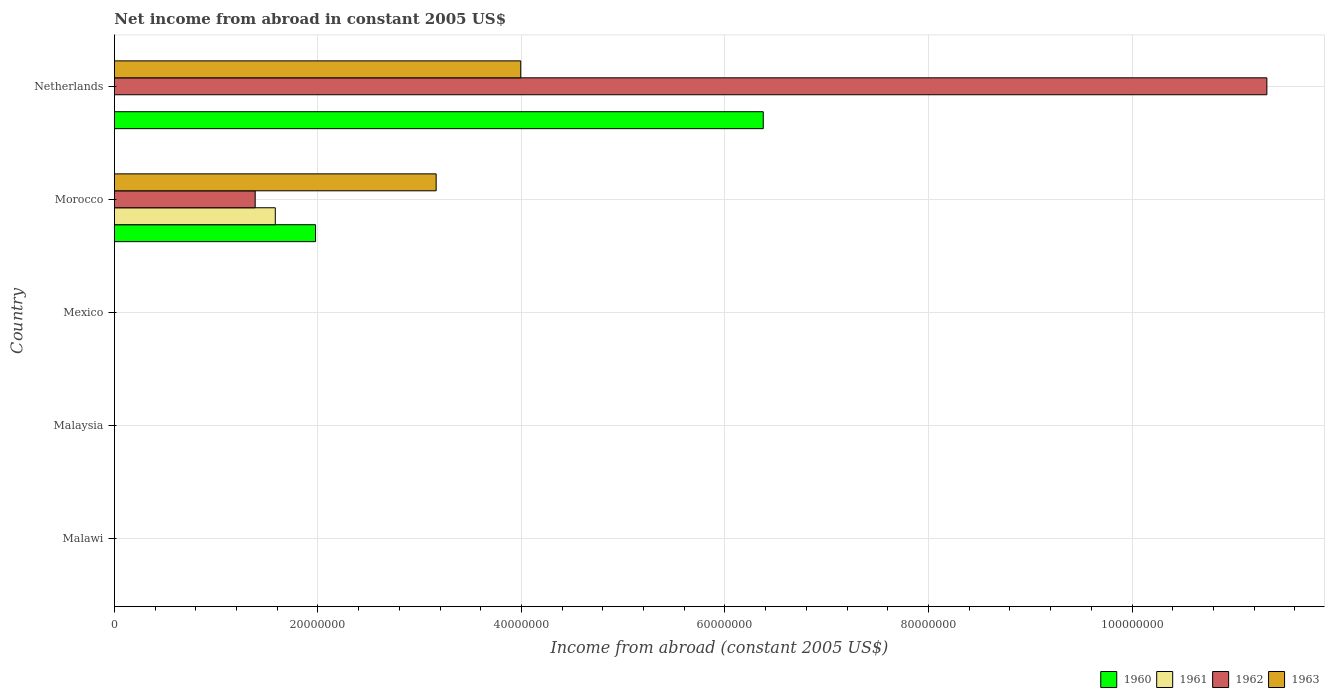Are the number of bars per tick equal to the number of legend labels?
Give a very brief answer. No. Are the number of bars on each tick of the Y-axis equal?
Ensure brevity in your answer.  No. What is the label of the 2nd group of bars from the top?
Your response must be concise. Morocco. In how many cases, is the number of bars for a given country not equal to the number of legend labels?
Ensure brevity in your answer.  4. Across all countries, what is the maximum net income from abroad in 1960?
Keep it short and to the point. 6.38e+07. Across all countries, what is the minimum net income from abroad in 1963?
Ensure brevity in your answer.  0. What is the total net income from abroad in 1961 in the graph?
Give a very brief answer. 1.58e+07. What is the difference between the net income from abroad in 1963 in Morocco and that in Netherlands?
Make the answer very short. -8.31e+06. What is the difference between the net income from abroad in 1961 in Morocco and the net income from abroad in 1962 in Malaysia?
Your response must be concise. 1.58e+07. What is the average net income from abroad in 1962 per country?
Give a very brief answer. 2.54e+07. What is the difference between the net income from abroad in 1963 and net income from abroad in 1962 in Morocco?
Provide a short and direct response. 1.78e+07. In how many countries, is the net income from abroad in 1961 greater than 96000000 US$?
Your response must be concise. 0. Is the difference between the net income from abroad in 1963 in Morocco and Netherlands greater than the difference between the net income from abroad in 1962 in Morocco and Netherlands?
Make the answer very short. Yes. What is the difference between the highest and the lowest net income from abroad in 1960?
Provide a short and direct response. 6.38e+07. In how many countries, is the net income from abroad in 1960 greater than the average net income from abroad in 1960 taken over all countries?
Give a very brief answer. 2. How many bars are there?
Your answer should be very brief. 7. Where does the legend appear in the graph?
Your answer should be very brief. Bottom right. How are the legend labels stacked?
Provide a succinct answer. Horizontal. What is the title of the graph?
Give a very brief answer. Net income from abroad in constant 2005 US$. What is the label or title of the X-axis?
Make the answer very short. Income from abroad (constant 2005 US$). What is the label or title of the Y-axis?
Keep it short and to the point. Country. What is the Income from abroad (constant 2005 US$) of 1960 in Malawi?
Provide a succinct answer. 0. What is the Income from abroad (constant 2005 US$) of 1961 in Malawi?
Make the answer very short. 0. What is the Income from abroad (constant 2005 US$) in 1962 in Malawi?
Your response must be concise. 0. What is the Income from abroad (constant 2005 US$) in 1963 in Malawi?
Provide a short and direct response. 0. What is the Income from abroad (constant 2005 US$) of 1960 in Malaysia?
Ensure brevity in your answer.  0. What is the Income from abroad (constant 2005 US$) in 1961 in Malaysia?
Your answer should be compact. 0. What is the Income from abroad (constant 2005 US$) of 1962 in Malaysia?
Give a very brief answer. 0. What is the Income from abroad (constant 2005 US$) in 1961 in Mexico?
Provide a succinct answer. 0. What is the Income from abroad (constant 2005 US$) of 1963 in Mexico?
Your response must be concise. 0. What is the Income from abroad (constant 2005 US$) of 1960 in Morocco?
Keep it short and to the point. 1.98e+07. What is the Income from abroad (constant 2005 US$) in 1961 in Morocco?
Give a very brief answer. 1.58e+07. What is the Income from abroad (constant 2005 US$) in 1962 in Morocco?
Provide a short and direct response. 1.38e+07. What is the Income from abroad (constant 2005 US$) in 1963 in Morocco?
Give a very brief answer. 3.16e+07. What is the Income from abroad (constant 2005 US$) of 1960 in Netherlands?
Provide a short and direct response. 6.38e+07. What is the Income from abroad (constant 2005 US$) of 1962 in Netherlands?
Offer a very short reply. 1.13e+08. What is the Income from abroad (constant 2005 US$) of 1963 in Netherlands?
Make the answer very short. 3.99e+07. Across all countries, what is the maximum Income from abroad (constant 2005 US$) in 1960?
Offer a terse response. 6.38e+07. Across all countries, what is the maximum Income from abroad (constant 2005 US$) in 1961?
Your response must be concise. 1.58e+07. Across all countries, what is the maximum Income from abroad (constant 2005 US$) of 1962?
Make the answer very short. 1.13e+08. Across all countries, what is the maximum Income from abroad (constant 2005 US$) in 1963?
Your answer should be very brief. 3.99e+07. Across all countries, what is the minimum Income from abroad (constant 2005 US$) of 1960?
Keep it short and to the point. 0. Across all countries, what is the minimum Income from abroad (constant 2005 US$) in 1961?
Provide a short and direct response. 0. What is the total Income from abroad (constant 2005 US$) in 1960 in the graph?
Your response must be concise. 8.35e+07. What is the total Income from abroad (constant 2005 US$) of 1961 in the graph?
Provide a succinct answer. 1.58e+07. What is the total Income from abroad (constant 2005 US$) in 1962 in the graph?
Make the answer very short. 1.27e+08. What is the total Income from abroad (constant 2005 US$) in 1963 in the graph?
Ensure brevity in your answer.  7.15e+07. What is the difference between the Income from abroad (constant 2005 US$) of 1960 in Morocco and that in Netherlands?
Keep it short and to the point. -4.40e+07. What is the difference between the Income from abroad (constant 2005 US$) in 1962 in Morocco and that in Netherlands?
Your answer should be compact. -9.94e+07. What is the difference between the Income from abroad (constant 2005 US$) of 1963 in Morocco and that in Netherlands?
Your response must be concise. -8.31e+06. What is the difference between the Income from abroad (constant 2005 US$) in 1960 in Morocco and the Income from abroad (constant 2005 US$) in 1962 in Netherlands?
Your answer should be very brief. -9.35e+07. What is the difference between the Income from abroad (constant 2005 US$) of 1960 in Morocco and the Income from abroad (constant 2005 US$) of 1963 in Netherlands?
Provide a short and direct response. -2.02e+07. What is the difference between the Income from abroad (constant 2005 US$) of 1961 in Morocco and the Income from abroad (constant 2005 US$) of 1962 in Netherlands?
Provide a short and direct response. -9.74e+07. What is the difference between the Income from abroad (constant 2005 US$) in 1961 in Morocco and the Income from abroad (constant 2005 US$) in 1963 in Netherlands?
Provide a short and direct response. -2.41e+07. What is the difference between the Income from abroad (constant 2005 US$) of 1962 in Morocco and the Income from abroad (constant 2005 US$) of 1963 in Netherlands?
Make the answer very short. -2.61e+07. What is the average Income from abroad (constant 2005 US$) in 1960 per country?
Your answer should be very brief. 1.67e+07. What is the average Income from abroad (constant 2005 US$) in 1961 per country?
Make the answer very short. 3.16e+06. What is the average Income from abroad (constant 2005 US$) in 1962 per country?
Offer a terse response. 2.54e+07. What is the average Income from abroad (constant 2005 US$) in 1963 per country?
Your response must be concise. 1.43e+07. What is the difference between the Income from abroad (constant 2005 US$) of 1960 and Income from abroad (constant 2005 US$) of 1961 in Morocco?
Your response must be concise. 3.95e+06. What is the difference between the Income from abroad (constant 2005 US$) of 1960 and Income from abroad (constant 2005 US$) of 1962 in Morocco?
Your answer should be very brief. 5.93e+06. What is the difference between the Income from abroad (constant 2005 US$) of 1960 and Income from abroad (constant 2005 US$) of 1963 in Morocco?
Offer a terse response. -1.19e+07. What is the difference between the Income from abroad (constant 2005 US$) in 1961 and Income from abroad (constant 2005 US$) in 1962 in Morocco?
Offer a very short reply. 1.98e+06. What is the difference between the Income from abroad (constant 2005 US$) in 1961 and Income from abroad (constant 2005 US$) in 1963 in Morocco?
Your answer should be compact. -1.58e+07. What is the difference between the Income from abroad (constant 2005 US$) in 1962 and Income from abroad (constant 2005 US$) in 1963 in Morocco?
Your response must be concise. -1.78e+07. What is the difference between the Income from abroad (constant 2005 US$) of 1960 and Income from abroad (constant 2005 US$) of 1962 in Netherlands?
Provide a short and direct response. -4.95e+07. What is the difference between the Income from abroad (constant 2005 US$) in 1960 and Income from abroad (constant 2005 US$) in 1963 in Netherlands?
Offer a very short reply. 2.38e+07. What is the difference between the Income from abroad (constant 2005 US$) of 1962 and Income from abroad (constant 2005 US$) of 1963 in Netherlands?
Your answer should be very brief. 7.33e+07. What is the ratio of the Income from abroad (constant 2005 US$) of 1960 in Morocco to that in Netherlands?
Offer a very short reply. 0.31. What is the ratio of the Income from abroad (constant 2005 US$) in 1962 in Morocco to that in Netherlands?
Offer a terse response. 0.12. What is the ratio of the Income from abroad (constant 2005 US$) in 1963 in Morocco to that in Netherlands?
Give a very brief answer. 0.79. What is the difference between the highest and the lowest Income from abroad (constant 2005 US$) in 1960?
Give a very brief answer. 6.38e+07. What is the difference between the highest and the lowest Income from abroad (constant 2005 US$) of 1961?
Give a very brief answer. 1.58e+07. What is the difference between the highest and the lowest Income from abroad (constant 2005 US$) of 1962?
Offer a very short reply. 1.13e+08. What is the difference between the highest and the lowest Income from abroad (constant 2005 US$) in 1963?
Give a very brief answer. 3.99e+07. 